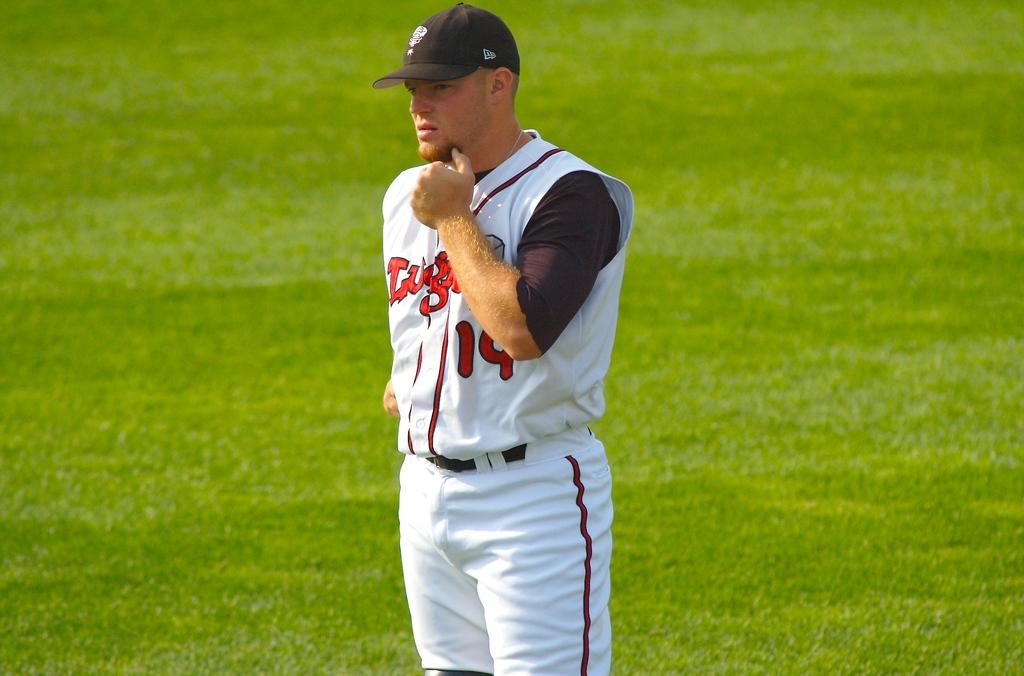Provide a one-sentence caption for the provided image. A baseball player in a white uniform with the number 19 in red. 